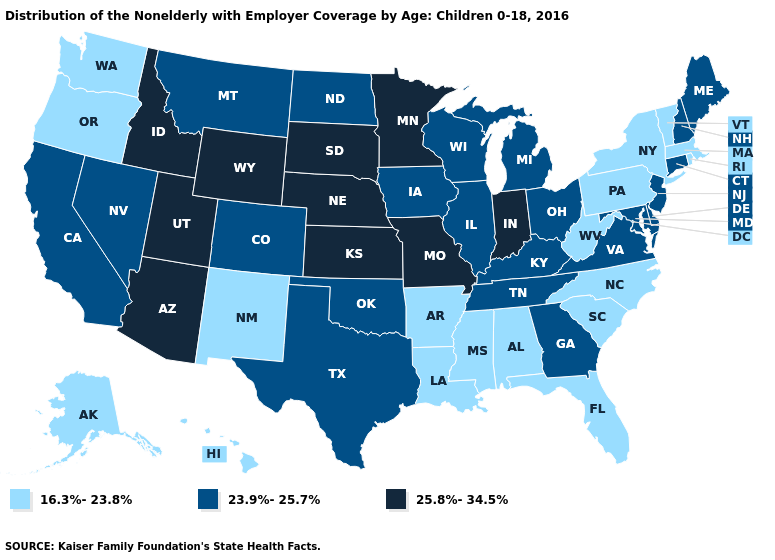Among the states that border California , which have the lowest value?
Answer briefly. Oregon. What is the highest value in the South ?
Quick response, please. 23.9%-25.7%. What is the value of Florida?
Short answer required. 16.3%-23.8%. What is the value of Pennsylvania?
Keep it brief. 16.3%-23.8%. Among the states that border Idaho , which have the highest value?
Be succinct. Utah, Wyoming. Among the states that border Colorado , does Oklahoma have the highest value?
Concise answer only. No. What is the value of Ohio?
Quick response, please. 23.9%-25.7%. What is the value of Maine?
Quick response, please. 23.9%-25.7%. Name the states that have a value in the range 23.9%-25.7%?
Write a very short answer. California, Colorado, Connecticut, Delaware, Georgia, Illinois, Iowa, Kentucky, Maine, Maryland, Michigan, Montana, Nevada, New Hampshire, New Jersey, North Dakota, Ohio, Oklahoma, Tennessee, Texas, Virginia, Wisconsin. What is the lowest value in states that border Tennessee?
Quick response, please. 16.3%-23.8%. What is the value of Oklahoma?
Be succinct. 23.9%-25.7%. Among the states that border California , which have the highest value?
Give a very brief answer. Arizona. What is the value of Utah?
Quick response, please. 25.8%-34.5%. Does Florida have the lowest value in the USA?
Be succinct. Yes. Does Wisconsin have the highest value in the MidWest?
Quick response, please. No. 